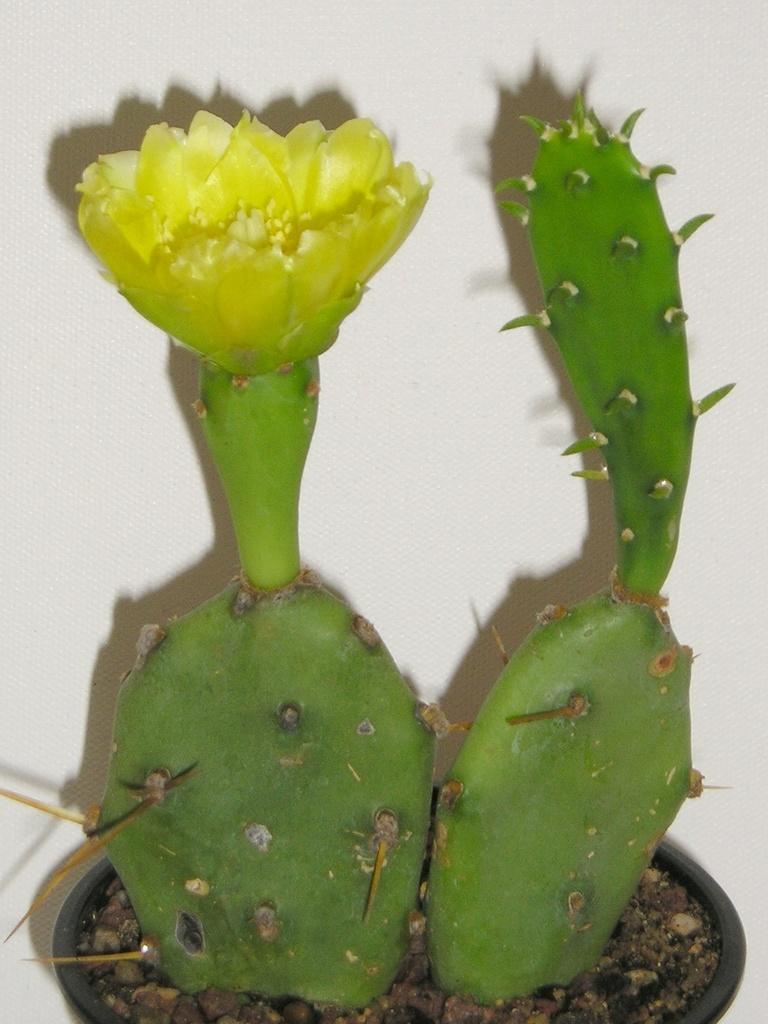How would you summarize this image in a sentence or two? In the middle of this image, there are two plants arranged in a pot. One of them is having a flower. In the background, there is a white wall. 